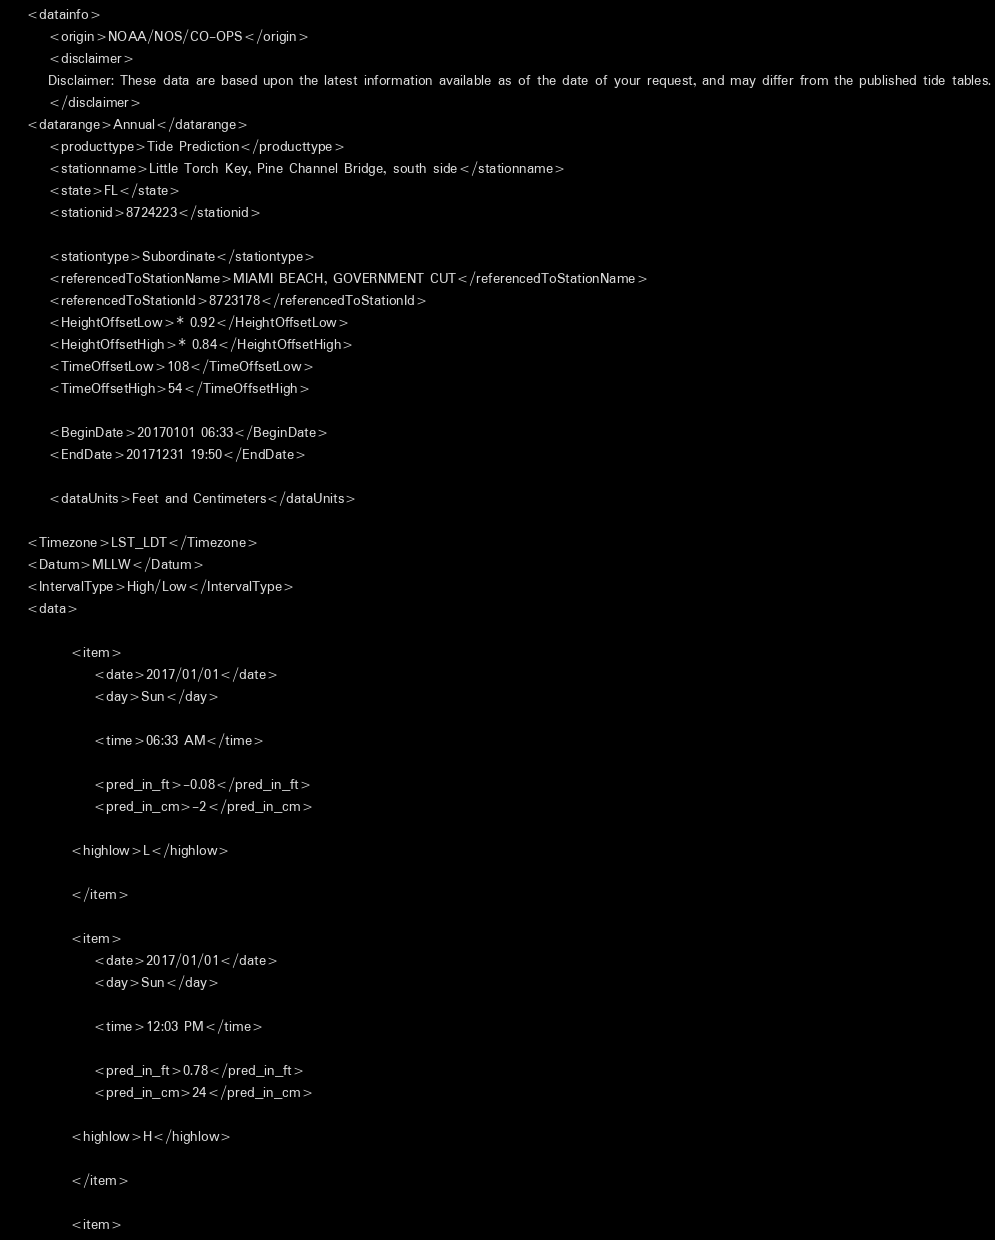<code> <loc_0><loc_0><loc_500><loc_500><_XML_>
	<datainfo>
		<origin>NOAA/NOS/CO-OPS</origin>
		<disclaimer>
		Disclaimer: These data are based upon the latest information available as of the date of your request, and may differ from the published tide tables.
		</disclaimer>
	<datarange>Annual</datarange>
		<producttype>Tide Prediction</producttype>
		<stationname>Little Torch Key, Pine Channel Bridge, south side</stationname>
		<state>FL</state>
		<stationid>8724223</stationid>
	
		<stationtype>Subordinate</stationtype>
		<referencedToStationName>MIAMI BEACH, GOVERNMENT CUT</referencedToStationName>
		<referencedToStationId>8723178</referencedToStationId>
		<HeightOffsetLow>* 0.92</HeightOffsetLow>
		<HeightOffsetHigh>* 0.84</HeightOffsetHigh>
		<TimeOffsetLow>108</TimeOffsetLow>
		<TimeOffsetHigh>54</TimeOffsetHigh>
		
		<BeginDate>20170101 06:33</BeginDate>
		<EndDate>20171231 19:50</EndDate>
		
		<dataUnits>Feet and Centimeters</dataUnits>
		 
	<Timezone>LST_LDT</Timezone>
	<Datum>MLLW</Datum>
	<IntervalType>High/Low</IntervalType>
	<data>
	
			<item>
				<date>2017/01/01</date>
				<day>Sun</day>
		
				<time>06:33 AM</time>
			
				<pred_in_ft>-0.08</pred_in_ft>
				<pred_in_cm>-2</pred_in_cm>
			
			<highlow>L</highlow>
			
			</item>
		
			<item>
				<date>2017/01/01</date>
				<day>Sun</day>
		
				<time>12:03 PM</time>
			
				<pred_in_ft>0.78</pred_in_ft>
				<pred_in_cm>24</pred_in_cm>
			
			<highlow>H</highlow>
			
			</item>
		
			<item></code> 